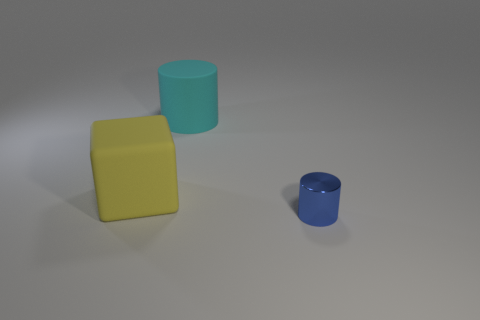Subtract 1 cubes. How many cubes are left? 0 Subtract all green blocks. Subtract all yellow cylinders. How many blocks are left? 1 Add 2 large cyan matte cylinders. How many objects exist? 5 Subtract all cylinders. How many objects are left? 1 Add 1 large blocks. How many large blocks exist? 2 Subtract 0 brown cubes. How many objects are left? 3 Subtract all big red metallic cubes. Subtract all rubber cylinders. How many objects are left? 2 Add 1 yellow cubes. How many yellow cubes are left? 2 